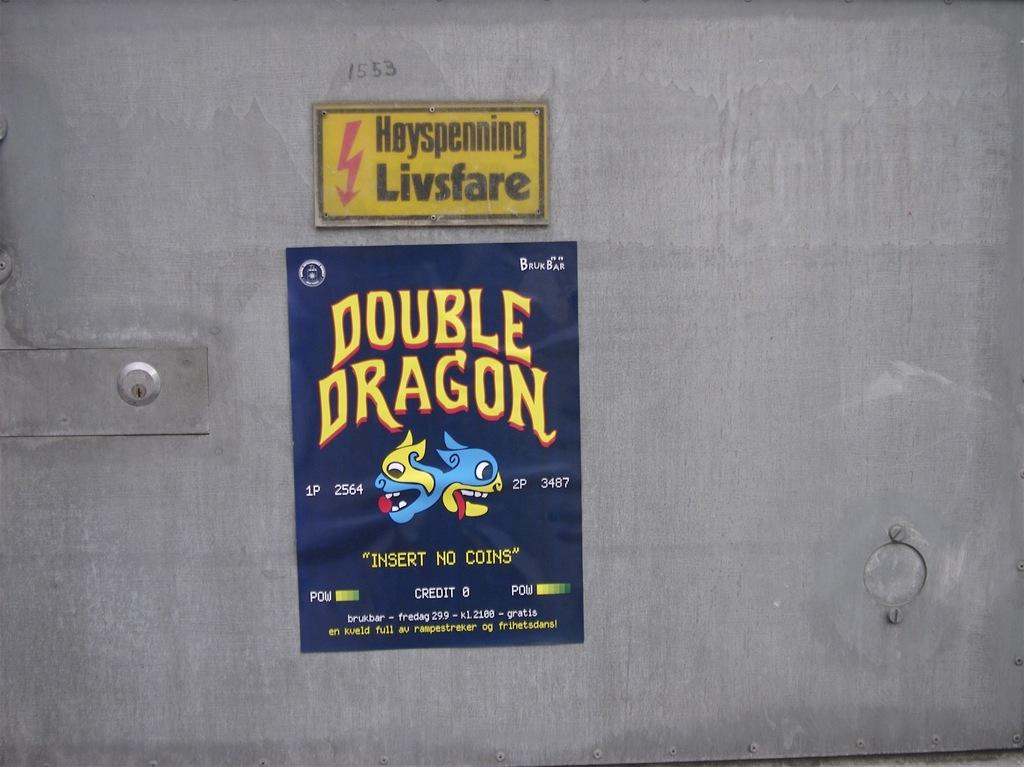<image>
Write a terse but informative summary of the picture. One should not insert any coins to play Double Dragon. 